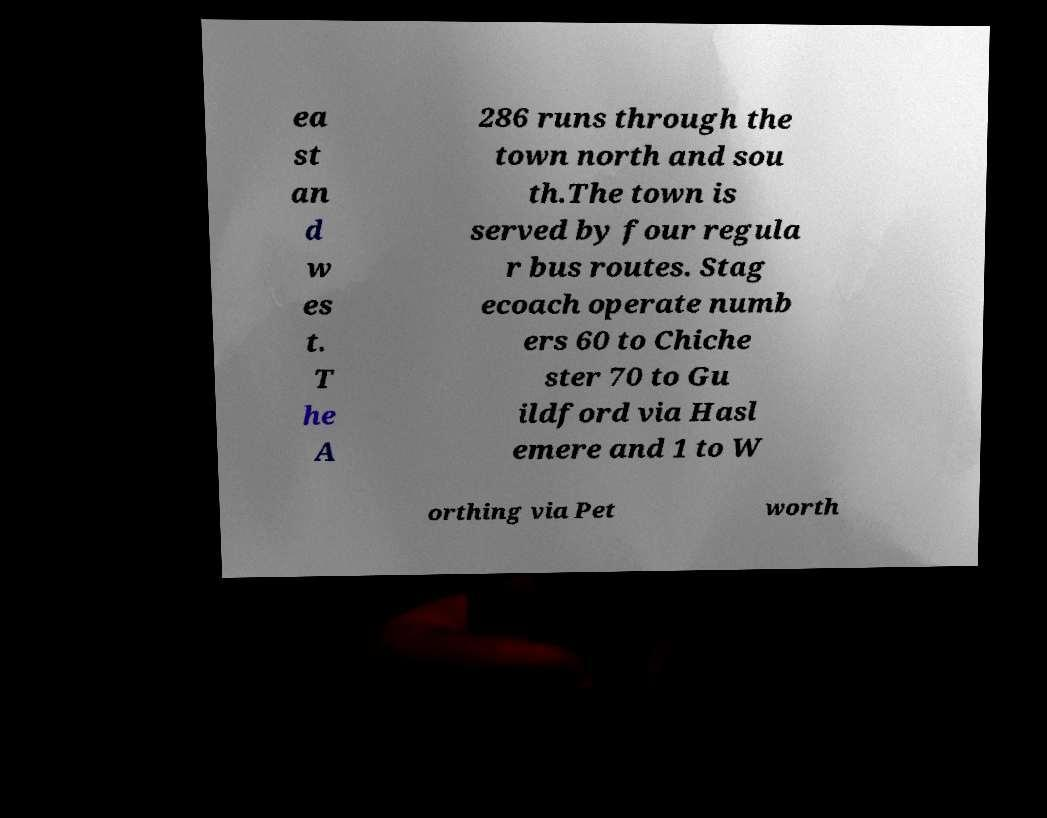Please identify and transcribe the text found in this image. ea st an d w es t. T he A 286 runs through the town north and sou th.The town is served by four regula r bus routes. Stag ecoach operate numb ers 60 to Chiche ster 70 to Gu ildford via Hasl emere and 1 to W orthing via Pet worth 